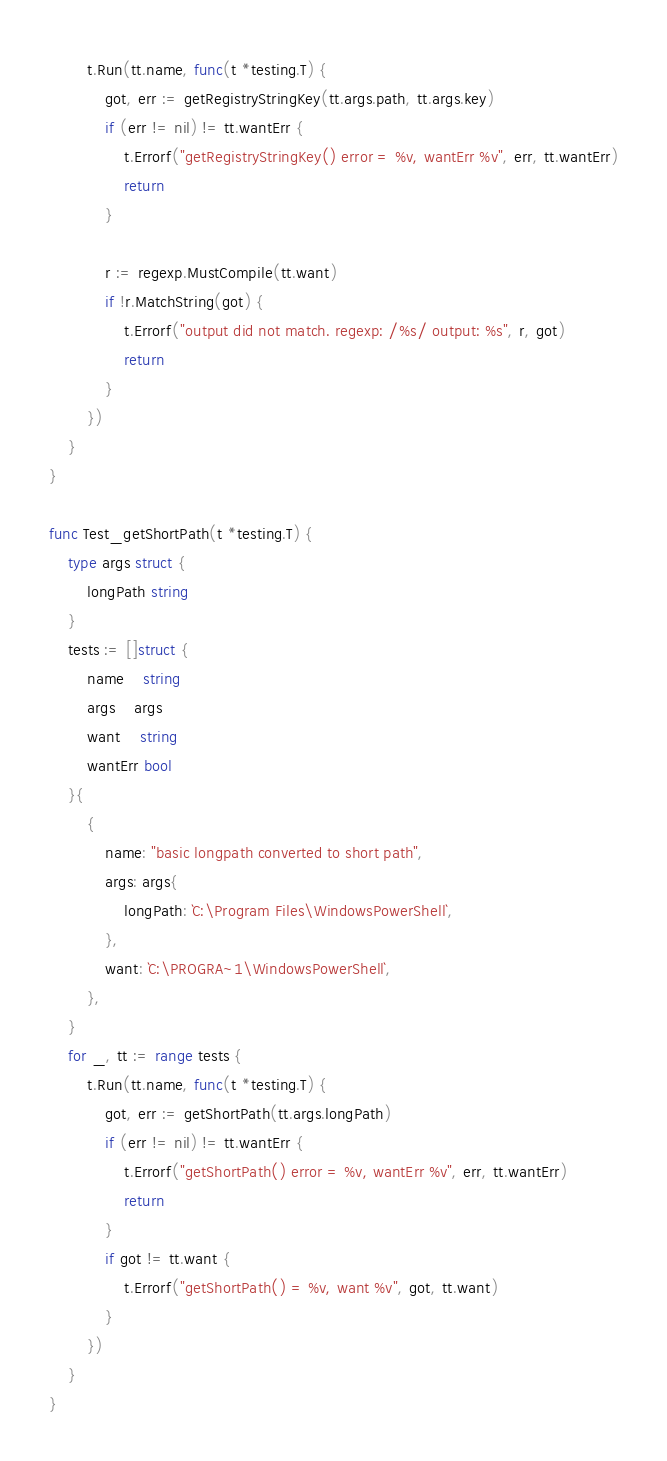<code> <loc_0><loc_0><loc_500><loc_500><_Go_>		t.Run(tt.name, func(t *testing.T) {
			got, err := getRegistryStringKey(tt.args.path, tt.args.key)
			if (err != nil) != tt.wantErr {
				t.Errorf("getRegistryStringKey() error = %v, wantErr %v", err, tt.wantErr)
				return
			}

			r := regexp.MustCompile(tt.want)
			if !r.MatchString(got) {
				t.Errorf("output did not match. regexp: /%s/ output: %s", r, got)
				return
			}
		})
	}
}

func Test_getShortPath(t *testing.T) {
	type args struct {
		longPath string
	}
	tests := []struct {
		name    string
		args    args
		want    string
		wantErr bool
	}{
		{
			name: "basic longpath converted to short path",
			args: args{
				longPath: `C:\Program Files\WindowsPowerShell`,
			},
			want: `C:\PROGRA~1\WindowsPowerShell`,
		},
	}
	for _, tt := range tests {
		t.Run(tt.name, func(t *testing.T) {
			got, err := getShortPath(tt.args.longPath)
			if (err != nil) != tt.wantErr {
				t.Errorf("getShortPath() error = %v, wantErr %v", err, tt.wantErr)
				return
			}
			if got != tt.want {
				t.Errorf("getShortPath() = %v, want %v", got, tt.want)
			}
		})
	}
}
</code> 